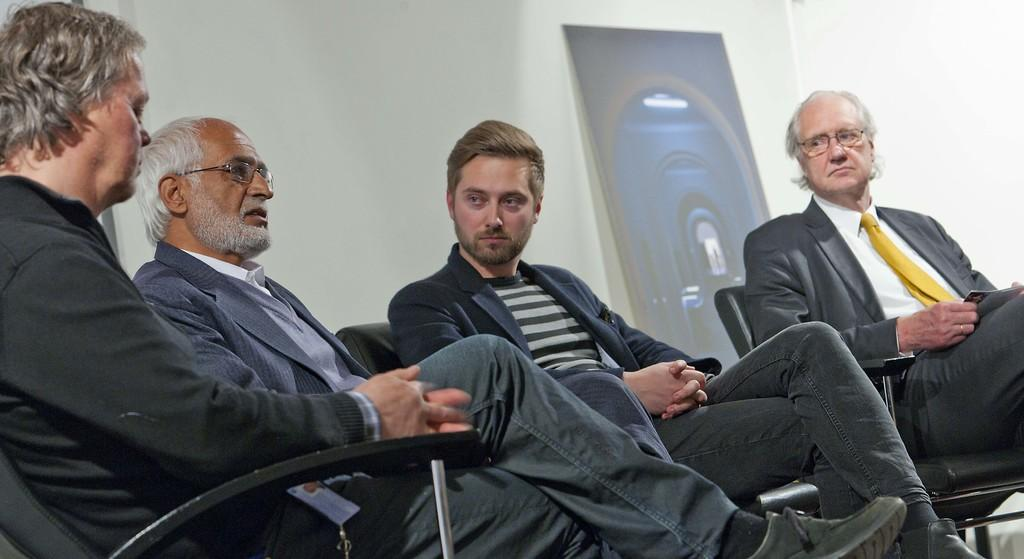What is happening in the image? There is a group of people in the image. What are the people doing in the image? The people are sitting on chairs. What can be seen in the background of the image? There is a poster in the background of the image. What type of zinc is present in the image? There is no zinc present in the image. How many minutes does it take for the people to finish their activity in the image? The image does not provide information about the duration of the activity, so it's impossible to determine how many minutes it takes for the people to finish. 